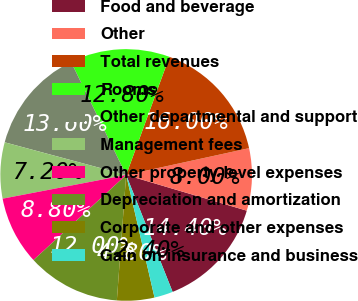Convert chart to OTSL. <chart><loc_0><loc_0><loc_500><loc_500><pie_chart><fcel>Food and beverage<fcel>Other<fcel>Total revenues<fcel>Rooms<fcel>Other departmental and support<fcel>Management fees<fcel>Other property-level expenses<fcel>Depreciation and amortization<fcel>Corporate and other expenses<fcel>Gain on insurance and business<nl><fcel>14.4%<fcel>8.0%<fcel>16.0%<fcel>12.8%<fcel>13.6%<fcel>7.2%<fcel>8.8%<fcel>12.0%<fcel>4.8%<fcel>2.4%<nl></chart> 